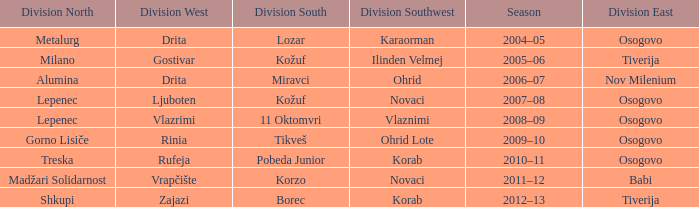Who won Division Southwest when the winner of Division North was Lepenec and Division South was won by 11 Oktomvri? Vlaznimi. 